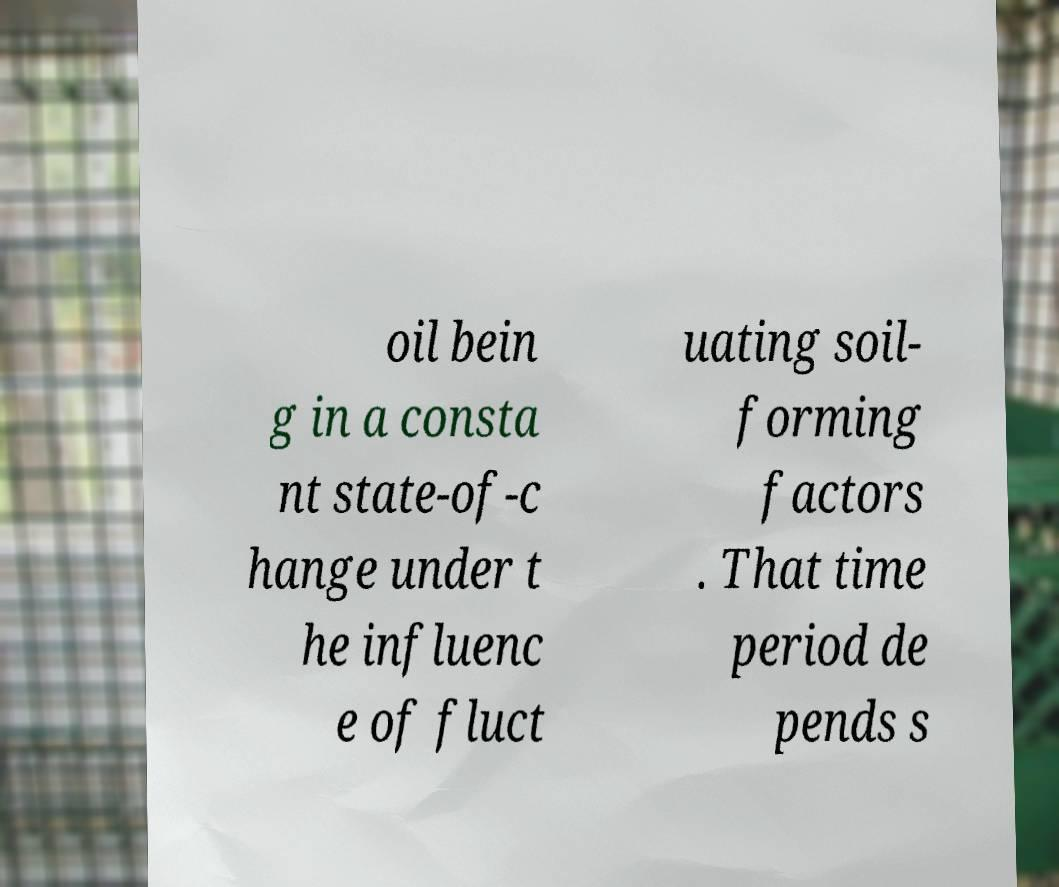Please identify and transcribe the text found in this image. oil bein g in a consta nt state-of-c hange under t he influenc e of fluct uating soil- forming factors . That time period de pends s 